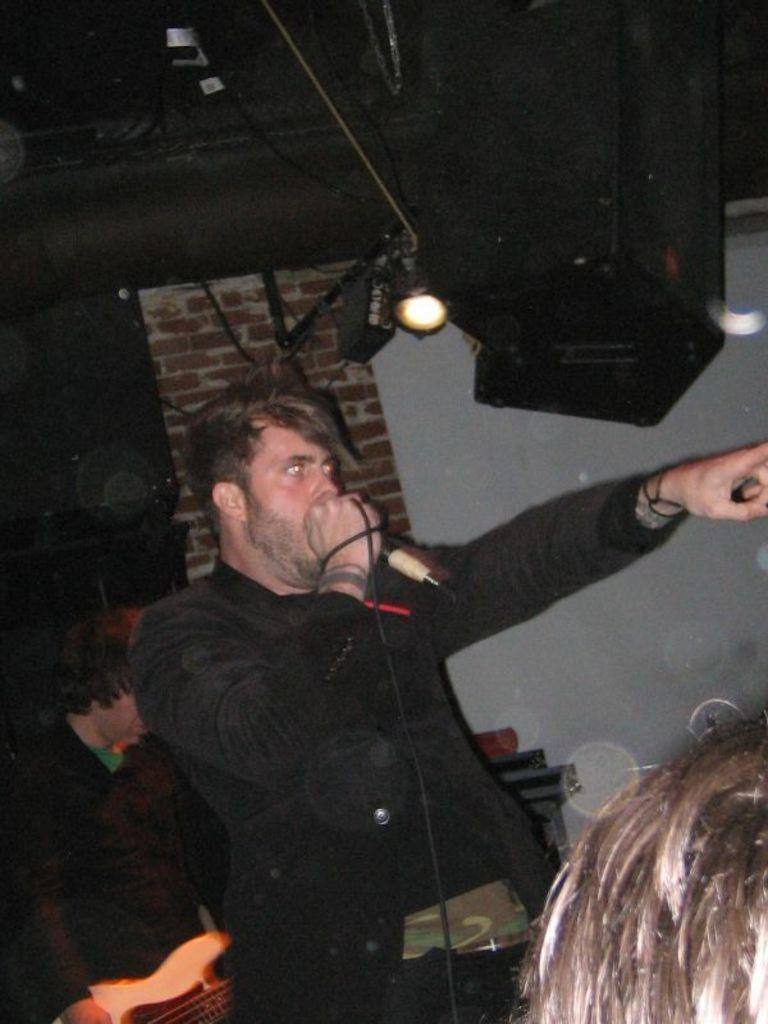What is happening in the image involving a group of people? There is a group of people in the image, and a man is singing in the middle of the group. How is the man singing in the image? The man is using a microphone while singing. What can be seen in the background of the image? There are lights visible in the background of the image. What type of disease is affecting the ladybug in the image? There is no ladybug present in the image, so it is not possible to determine if a disease is affecting it. 